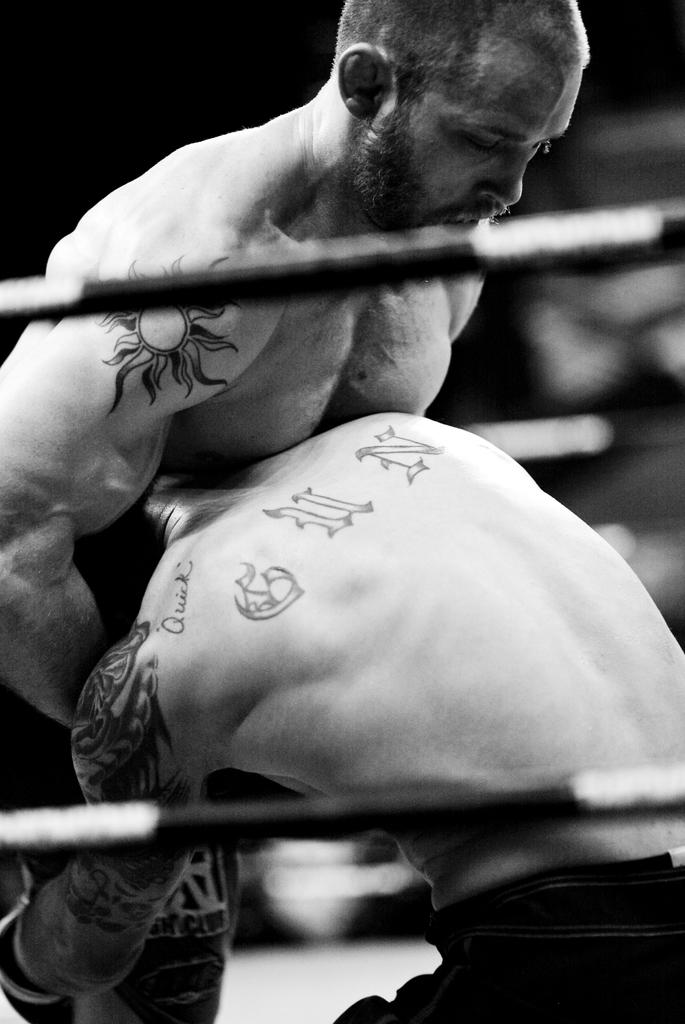How many people are in the image? There are two persons in the image. What are the two persons doing? The two persons appear to be fighting. What can be seen at the top of the image? There is a rope at the top of the image. What can be seen at the bottom of the image? There is a rope at the bottom of the image. What is the interest rate of the loan in the image? There is no mention of a loan or interest rate in the image; it features two people fighting and ropes at the top and bottom. 